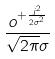<formula> <loc_0><loc_0><loc_500><loc_500>\frac { o ^ { + \frac { j ^ { 2 } } { 2 \sigma ^ { 2 } } } } { \sqrt { 2 \pi } \sigma }</formula> 